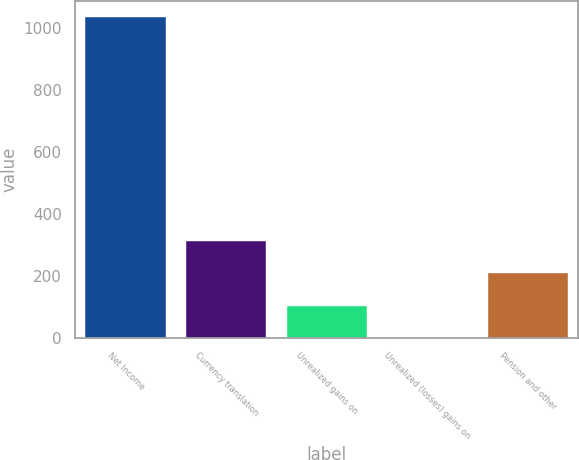Convert chart. <chart><loc_0><loc_0><loc_500><loc_500><bar_chart><fcel>Net Income<fcel>Currency translation<fcel>Unrealized gains on<fcel>Unrealized (losses) gains on<fcel>Pension and other<nl><fcel>1035.6<fcel>310.82<fcel>103.74<fcel>0.2<fcel>207.28<nl></chart> 